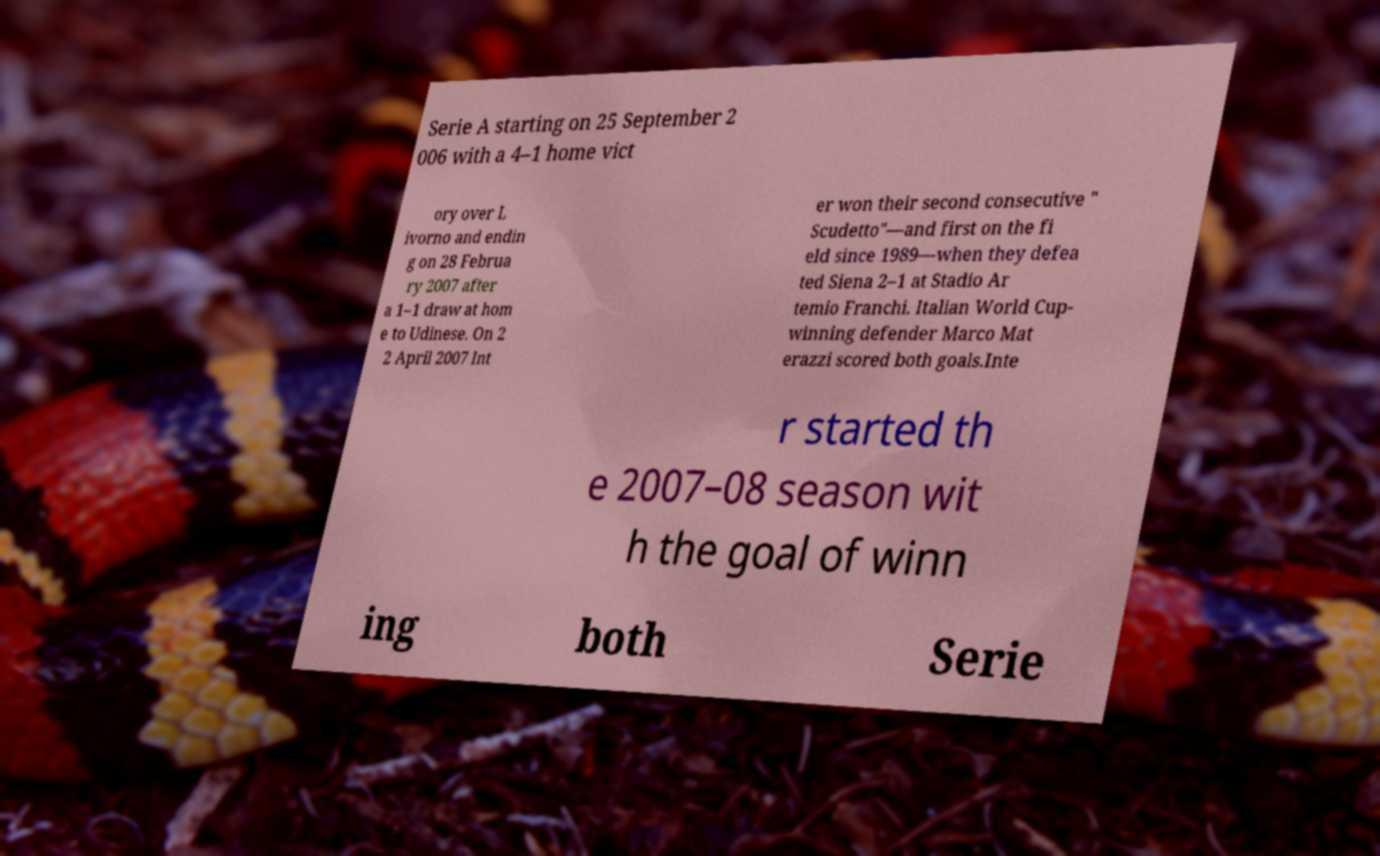For documentation purposes, I need the text within this image transcribed. Could you provide that? Serie A starting on 25 September 2 006 with a 4–1 home vict ory over L ivorno and endin g on 28 Februa ry 2007 after a 1–1 draw at hom e to Udinese. On 2 2 April 2007 Int er won their second consecutive " Scudetto"—and first on the fi eld since 1989—when they defea ted Siena 2–1 at Stadio Ar temio Franchi. Italian World Cup- winning defender Marco Mat erazzi scored both goals.Inte r started th e 2007–08 season wit h the goal of winn ing both Serie 